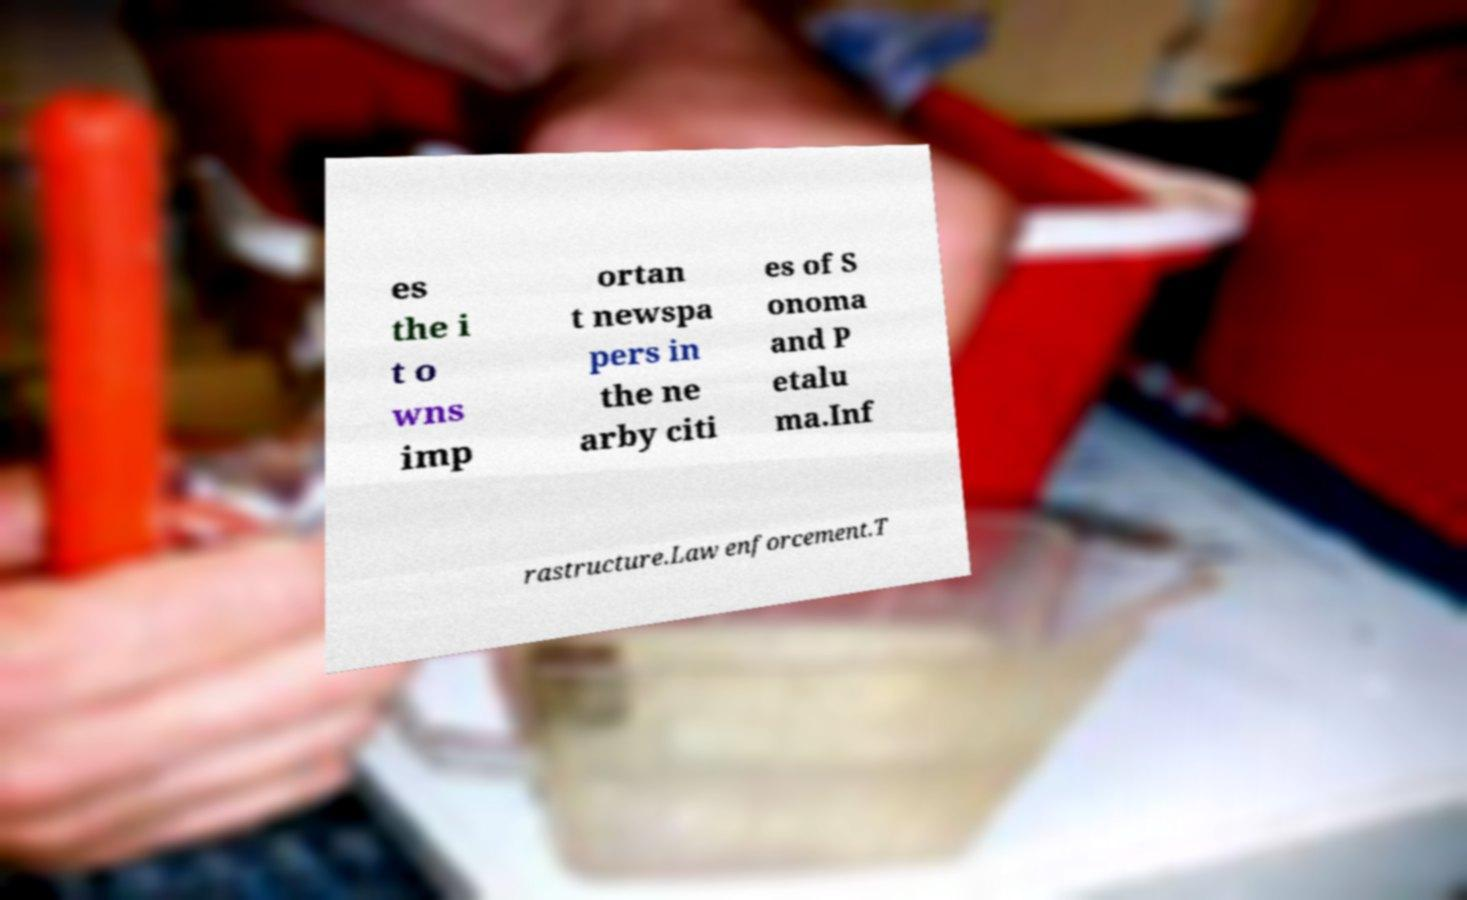I need the written content from this picture converted into text. Can you do that? es the i t o wns imp ortan t newspa pers in the ne arby citi es of S onoma and P etalu ma.Inf rastructure.Law enforcement.T 